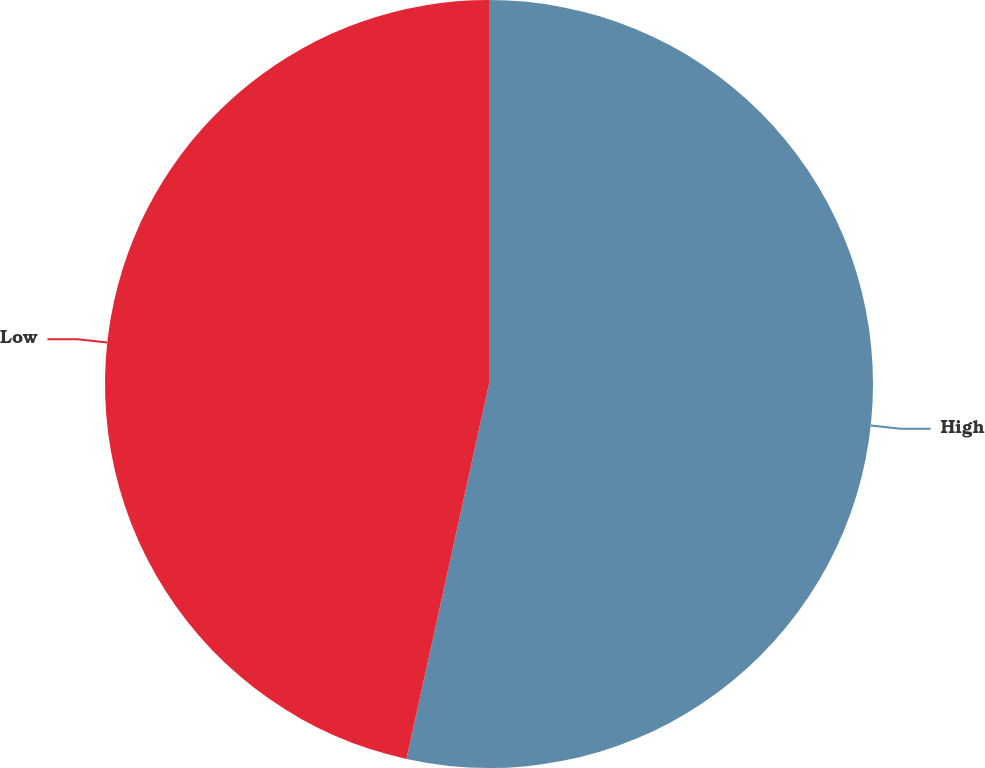<chart> <loc_0><loc_0><loc_500><loc_500><pie_chart><fcel>High<fcel>Low<nl><fcel>53.45%<fcel>46.55%<nl></chart> 